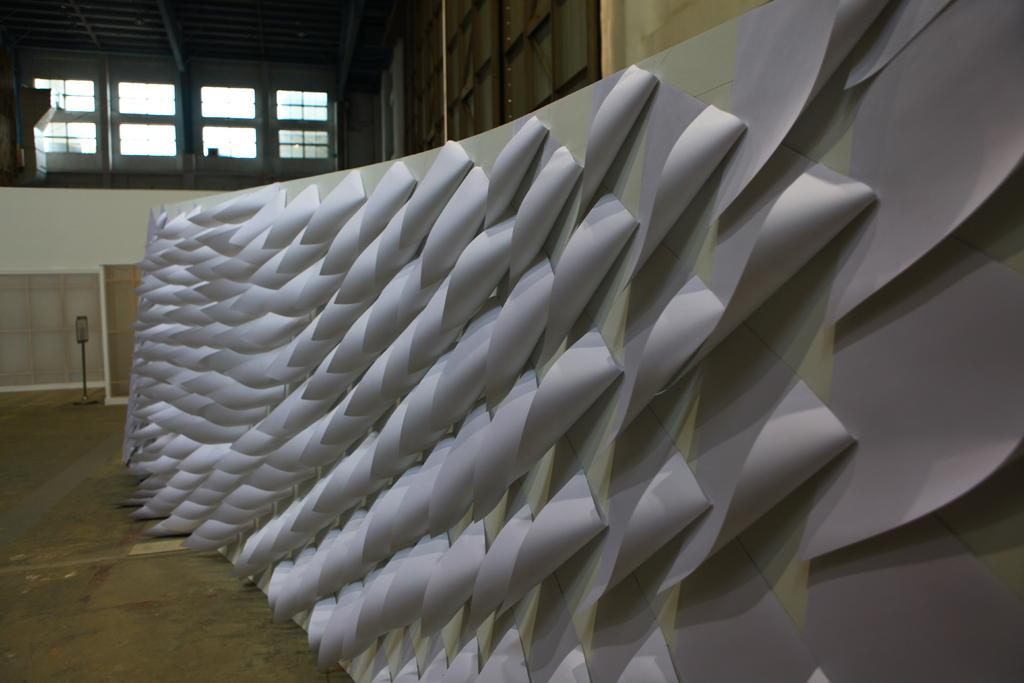What is placed on the white surface in the image? There are papers on a white surface. What can be seen in the background of the image? There are windows, a wall, and a stand in the background. Are there any objects visible in the background? Yes, there are objects in the background. What type of branch can be seen holding a mitten during the feast in the image? There is no branch, mitten, or feast present in the image. 